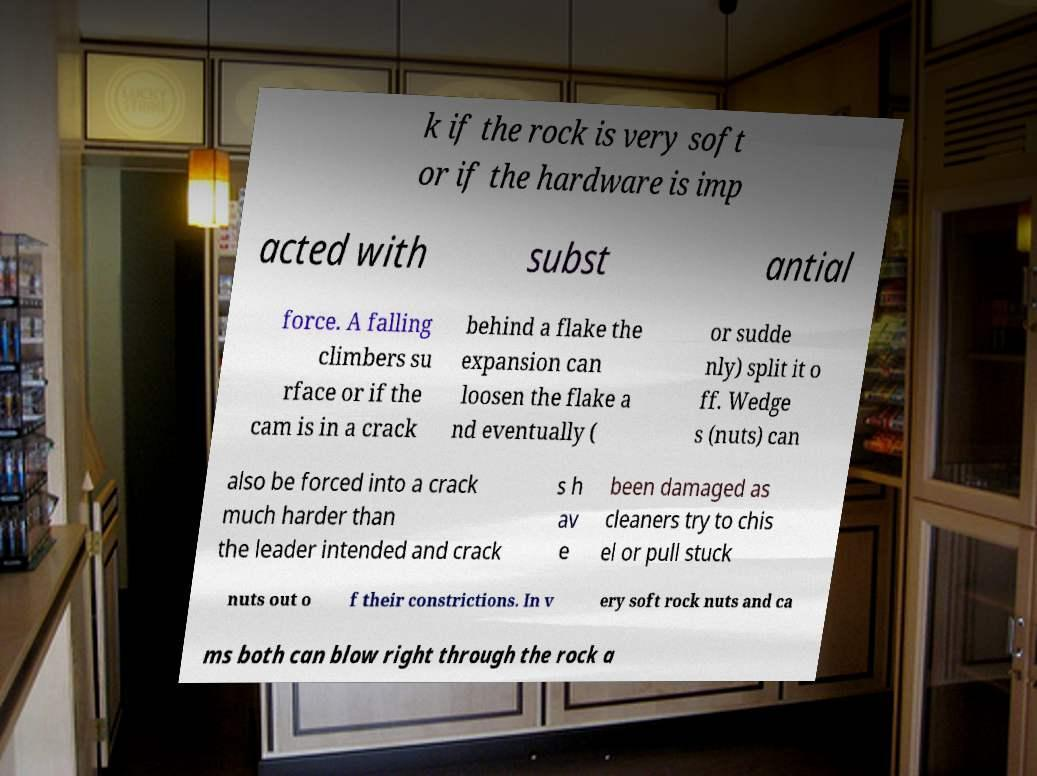Please read and relay the text visible in this image. What does it say? k if the rock is very soft or if the hardware is imp acted with subst antial force. A falling climbers su rface or if the cam is in a crack behind a flake the expansion can loosen the flake a nd eventually ( or sudde nly) split it o ff. Wedge s (nuts) can also be forced into a crack much harder than the leader intended and crack s h av e been damaged as cleaners try to chis el or pull stuck nuts out o f their constrictions. In v ery soft rock nuts and ca ms both can blow right through the rock a 